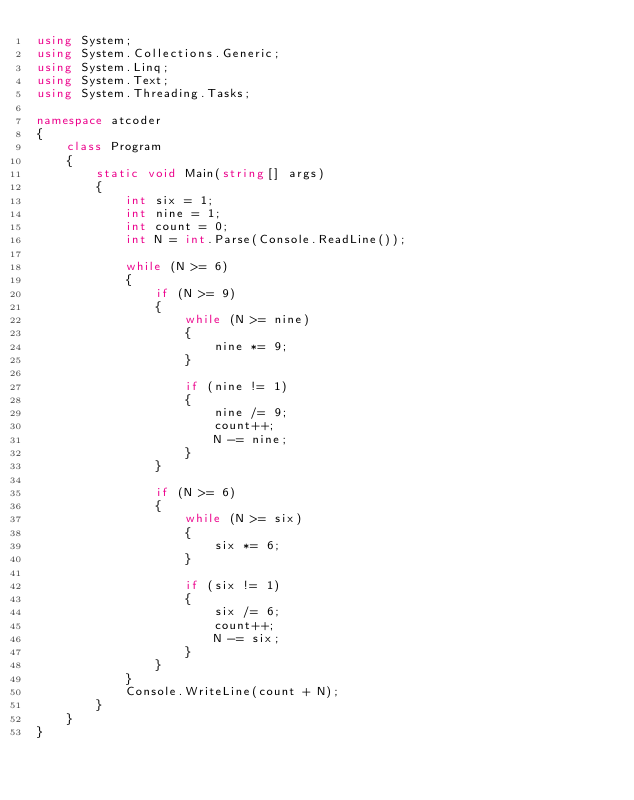Convert code to text. <code><loc_0><loc_0><loc_500><loc_500><_C#_>using System;
using System.Collections.Generic;
using System.Linq;
using System.Text;
using System.Threading.Tasks;

namespace atcoder
{
    class Program
    {
        static void Main(string[] args)
        {
            int six = 1;
            int nine = 1;
            int count = 0;
            int N = int.Parse(Console.ReadLine());

            while (N >= 6)
            {
                if (N >= 9)
                {
                    while (N >= nine)
                    {
                        nine *= 9;
                    }

                    if (nine != 1)
                    {
                        nine /= 9;
                        count++;
                        N -= nine;
                    }
                }

                if (N >= 6)
                {
                    while (N >= six)
                    {
                        six *= 6;
                    }

                    if (six != 1)
                    {
                        six /= 6;
                        count++;
                        N -= six;
                    }
                }
            }
            Console.WriteLine(count + N);
        }
    }
}</code> 